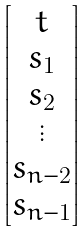Convert formula to latex. <formula><loc_0><loc_0><loc_500><loc_500>\begin{bmatrix} t \\ s _ { 1 } \\ s _ { 2 } \\ \vdots \\ s _ { n - 2 } \\ s _ { n - 1 } \end{bmatrix}</formula> 